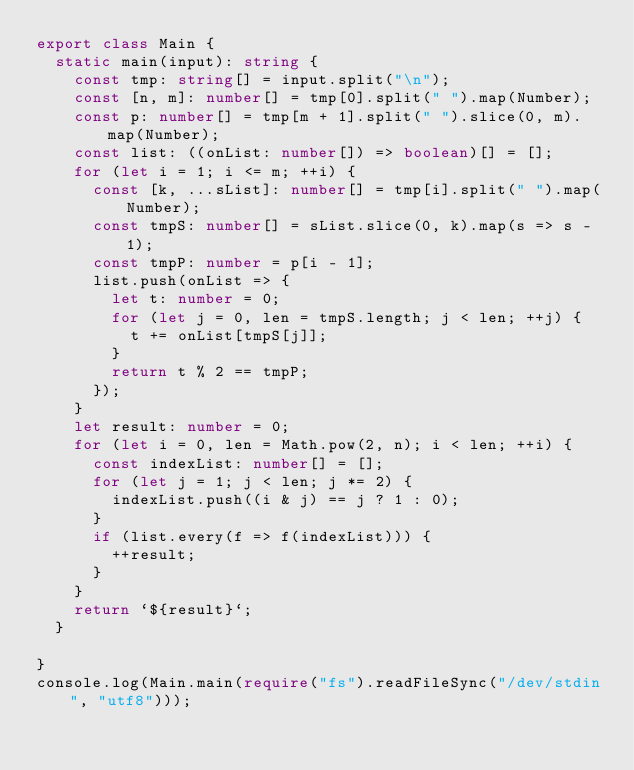<code> <loc_0><loc_0><loc_500><loc_500><_TypeScript_>export class Main {
  static main(input): string {
    const tmp: string[] = input.split("\n");
    const [n, m]: number[] = tmp[0].split(" ").map(Number);
    const p: number[] = tmp[m + 1].split(" ").slice(0, m).map(Number);
    const list: ((onList: number[]) => boolean)[] = [];
    for (let i = 1; i <= m; ++i) {
      const [k, ...sList]: number[] = tmp[i].split(" ").map(Number);
      const tmpS: number[] = sList.slice(0, k).map(s => s - 1);
      const tmpP: number = p[i - 1];
      list.push(onList => {
        let t: number = 0;
        for (let j = 0, len = tmpS.length; j < len; ++j) {
          t += onList[tmpS[j]];
        }
        return t % 2 == tmpP;
      });
    }
    let result: number = 0;
    for (let i = 0, len = Math.pow(2, n); i < len; ++i) {
      const indexList: number[] = [];
      for (let j = 1; j < len; j *= 2) {
        indexList.push((i & j) == j ? 1 : 0);
      }
      if (list.every(f => f(indexList))) {
        ++result;
      }
    }
    return `${result}`;
  }

}
console.log(Main.main(require("fs").readFileSync("/dev/stdin", "utf8")));</code> 